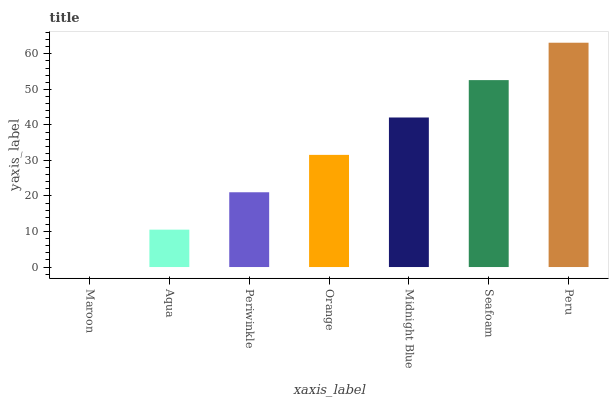Is Maroon the minimum?
Answer yes or no. Yes. Is Peru the maximum?
Answer yes or no. Yes. Is Aqua the minimum?
Answer yes or no. No. Is Aqua the maximum?
Answer yes or no. No. Is Aqua greater than Maroon?
Answer yes or no. Yes. Is Maroon less than Aqua?
Answer yes or no. Yes. Is Maroon greater than Aqua?
Answer yes or no. No. Is Aqua less than Maroon?
Answer yes or no. No. Is Orange the high median?
Answer yes or no. Yes. Is Orange the low median?
Answer yes or no. Yes. Is Maroon the high median?
Answer yes or no. No. Is Maroon the low median?
Answer yes or no. No. 